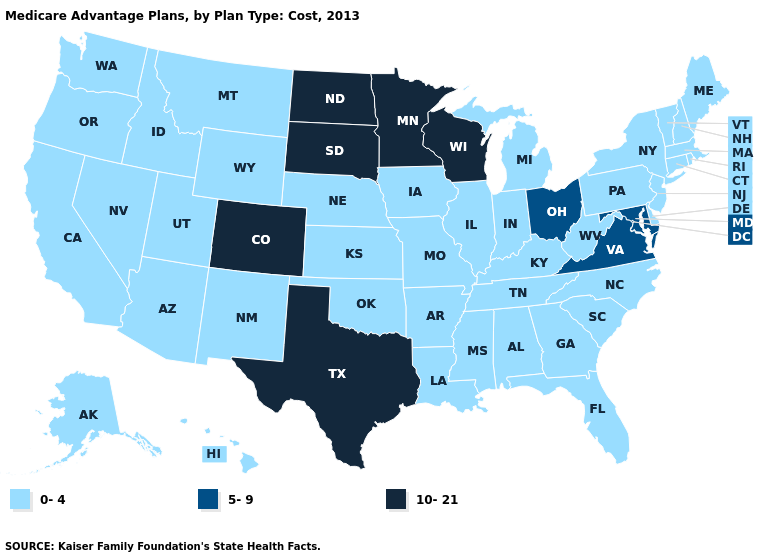Among the states that border Iowa , which have the lowest value?
Be succinct. Illinois, Missouri, Nebraska. Among the states that border Massachusetts , which have the lowest value?
Keep it brief. Connecticut, New Hampshire, New York, Rhode Island, Vermont. Name the states that have a value in the range 10-21?
Write a very short answer. Colorado, Minnesota, North Dakota, South Dakota, Texas, Wisconsin. Does Alabama have the same value as Iowa?
Quick response, please. Yes. Does Nevada have the highest value in the USA?
Keep it brief. No. What is the value of New Mexico?
Quick response, please. 0-4. Name the states that have a value in the range 5-9?
Be succinct. Maryland, Ohio, Virginia. What is the value of Michigan?
Write a very short answer. 0-4. What is the value of New Jersey?
Concise answer only. 0-4. How many symbols are there in the legend?
Be succinct. 3. What is the value of Wisconsin?
Short answer required. 10-21. What is the value of Mississippi?
Be succinct. 0-4. How many symbols are there in the legend?
Write a very short answer. 3. What is the value of Connecticut?
Keep it brief. 0-4. Name the states that have a value in the range 0-4?
Give a very brief answer. Alaska, Alabama, Arkansas, Arizona, California, Connecticut, Delaware, Florida, Georgia, Hawaii, Iowa, Idaho, Illinois, Indiana, Kansas, Kentucky, Louisiana, Massachusetts, Maine, Michigan, Missouri, Mississippi, Montana, North Carolina, Nebraska, New Hampshire, New Jersey, New Mexico, Nevada, New York, Oklahoma, Oregon, Pennsylvania, Rhode Island, South Carolina, Tennessee, Utah, Vermont, Washington, West Virginia, Wyoming. 